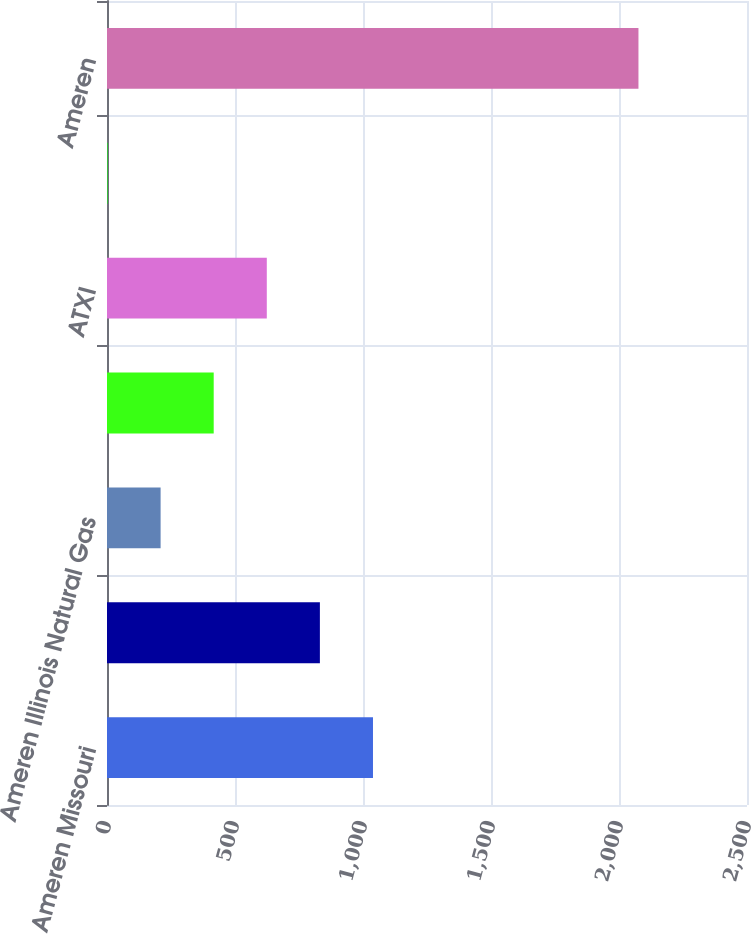Convert chart. <chart><loc_0><loc_0><loc_500><loc_500><bar_chart><fcel>Ameren Missouri<fcel>Ameren Illinois Electric<fcel>Ameren Illinois Natural Gas<fcel>Ameren Illinois Transmission<fcel>ATXI<fcel>Other (a)<fcel>Ameren<nl><fcel>1039<fcel>831.6<fcel>209.4<fcel>416.8<fcel>624.2<fcel>2<fcel>2076<nl></chart> 